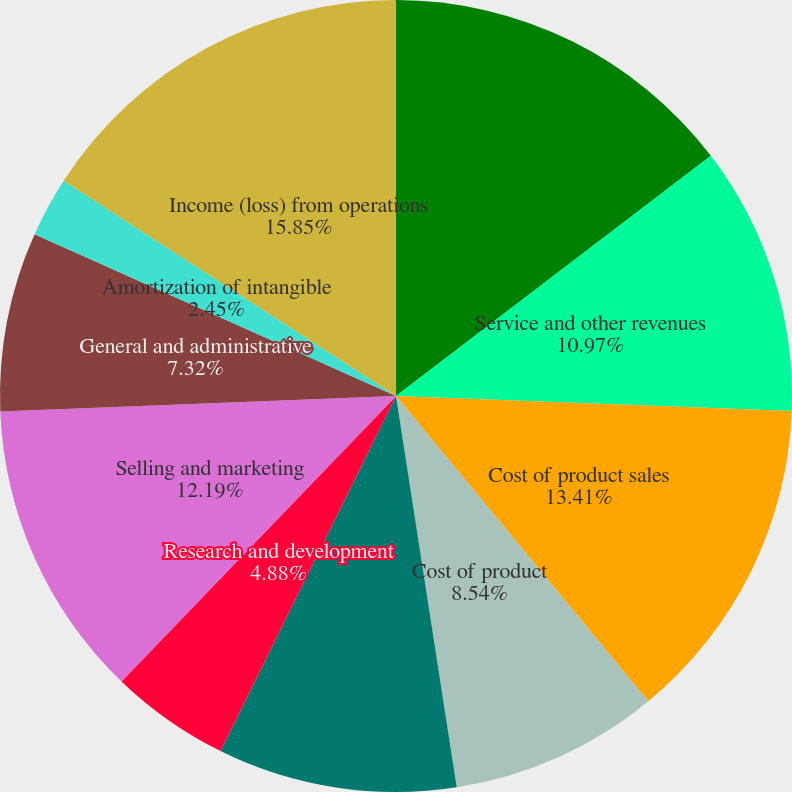<chart> <loc_0><loc_0><loc_500><loc_500><pie_chart><fcel>Product sales<fcel>Service and other revenues<fcel>Cost of product sales<fcel>Cost of product<fcel>Cost of service and other<fcel>Research and development<fcel>Selling and marketing<fcel>General and administrative<fcel>Amortization of intangible<fcel>Income (loss) from operations<nl><fcel>14.63%<fcel>10.97%<fcel>13.41%<fcel>8.54%<fcel>9.76%<fcel>4.88%<fcel>12.19%<fcel>7.32%<fcel>2.45%<fcel>15.85%<nl></chart> 